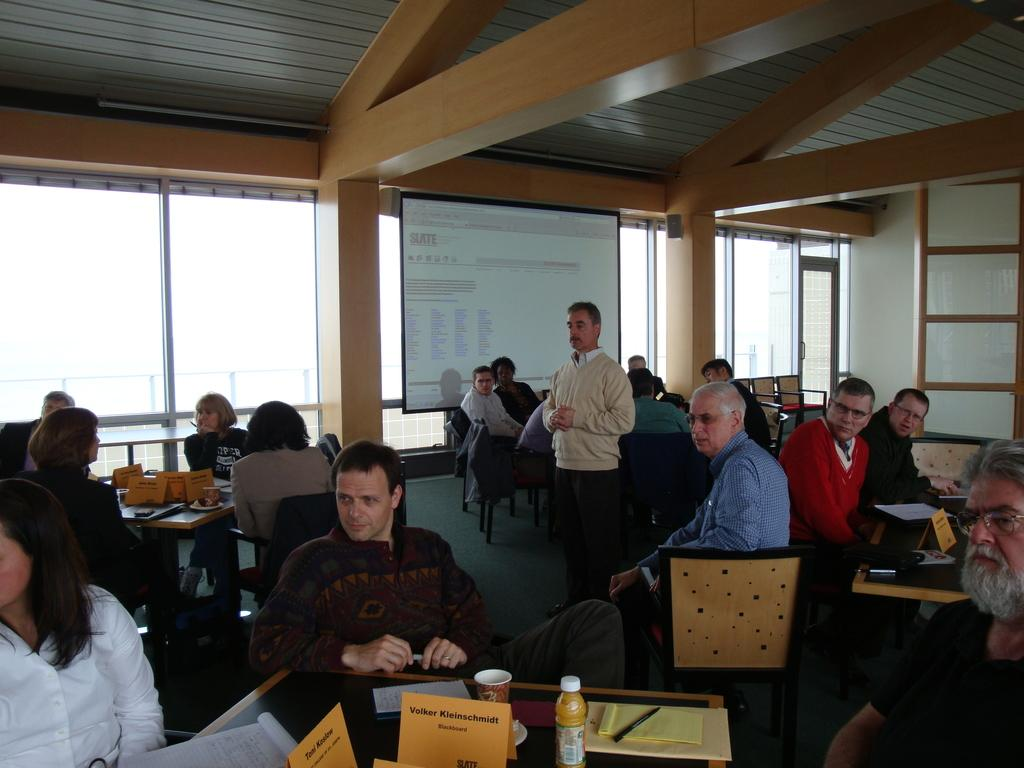What are the people in the image doing? The people in the image are sitting on chairs. What is in front of the people? There is a table in front of the people. Is there anyone standing in the image? Yes, there is a person standing between the people. What type of oatmeal is being served on the map in the image? There is no map or oatmeal present in the image. What type of voyage are the people planning in the image? There is no indication of a voyage or any related planning in the image. 